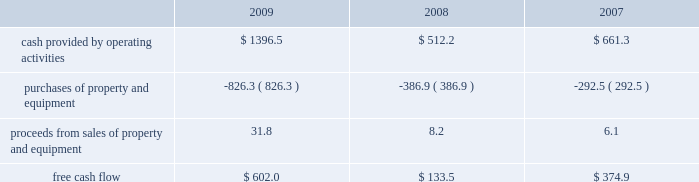Failure to comply with the financial and other covenants under our credit facilities , as well as the occurrence of certain material adverse events , would constitute defaults and would allow the lenders under our credit facilities to accelerate the maturity of all indebtedness under the related agreements .
This could also have an adverse impact on the availability of financial assurances .
In addition , maturity acceleration on our credit facilities constitutes an event of default under our other debt instruments , including our senior notes , and , therefore , our senior notes would also be subject to acceleration of maturity .
If such acceleration were to occur , we would not have sufficient liquidity available to repay the indebtedness .
We would likely have to seek an amendment under our credit facilities for relief from the financial covenants or repay the debt with proceeds from the issuance of new debt or equity , or asset sales , if necessary .
We may be unable to amend our credit facilities or raise sufficient capital to repay such obligations in the event the maturities are accelerated .
Financial assurance we are required to provide financial assurance to governmental agencies and a variety of other entities under applicable environmental regulations relating to our landfill operations for capping , closure and post-closure costs , and related to our performance under certain collection , landfill and transfer station contracts .
We satisfy these financial assurance requirements by providing surety bonds , letters of credit , insurance policies or trust deposits .
The amount of the financial assurance requirements for capping , closure and post-closure costs is determined by applicable state environmental regulations .
The financial assurance requirements for capping , closure and post-closure costs may be associated with a portion of the landfill or the entire landfill .
Generally , states will require a third-party engineering specialist to determine the estimated capping , closure and post- closure costs that are used to determine the required amount of financial assurance for a landfill .
The amount of financial assurance required can , and generally will , differ from the obligation determined and recorded under u.s .
Gaap .
The amount of the financial assurance requirements related to contract performance varies by contract .
Additionally , we are required to provide financial assurance for our insurance program and collateral for certain performance obligations .
We do not expect a material increase in financial assurance requirements during 2010 , although the mix of financial assurance instruments may change .
These financial instruments are issued in the normal course of business and are not debt of our company .
Since we currently have no liability for these financial assurance instruments , they are not reflected in our consolidated balance sheets .
However , we record capping , closure and post-closure liabilities and self-insurance liabilities as they are incurred .
The underlying obligations of the financial assurance instruments , in excess of those already reflected in our consolidated balance sheets , would be recorded if it is probable that we would be unable to fulfill our related obligations .
We do not expect this to occur .
Off-balance sheet arrangements we have no off-balance sheet debt or similar obligations , other than financial assurance instruments and operating leases that are not classified as debt .
We do not guarantee any third-party debt .
Free cash flow we define free cash flow , which is not a measure determined in accordance with u.s .
Gaap , as cash provided by operating activities less purchases of property and equipment , plus proceeds from sales of property and equipment as presented in our consolidated statements of cash flows .
Our free cash flow for the years ended december 31 , 2009 , 2008 and 2007 is calculated as follows ( in millions ) : .

What was the percentage decline in the cash provided by operating activities from 2007 to 2008? 
Rationale: the percentage decline is the difference between the most current and prior amount divide by the prior amount
Computations: ((512.2 - 661.3) / 661.3)
Answer: -0.22546. 